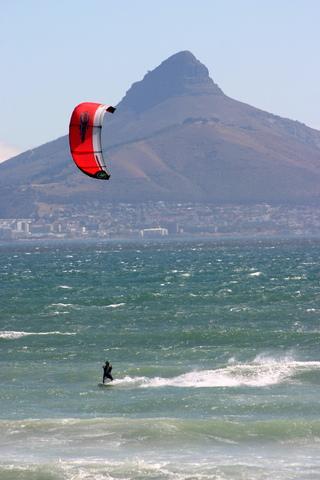Is there a mountain in the background?
Be succinct. Yes. What activity is this person doing?
Give a very brief answer. Windsurfing. Is there a city on the ocean?
Give a very brief answer. Yes. 